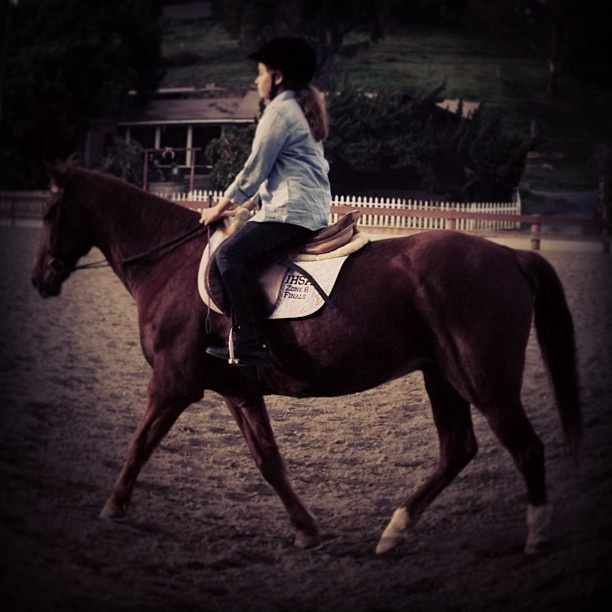Describe the objects in this image and their specific colors. I can see horse in black, maroon, brown, and lightgray tones and people in black, gray, darkgray, and tan tones in this image. 